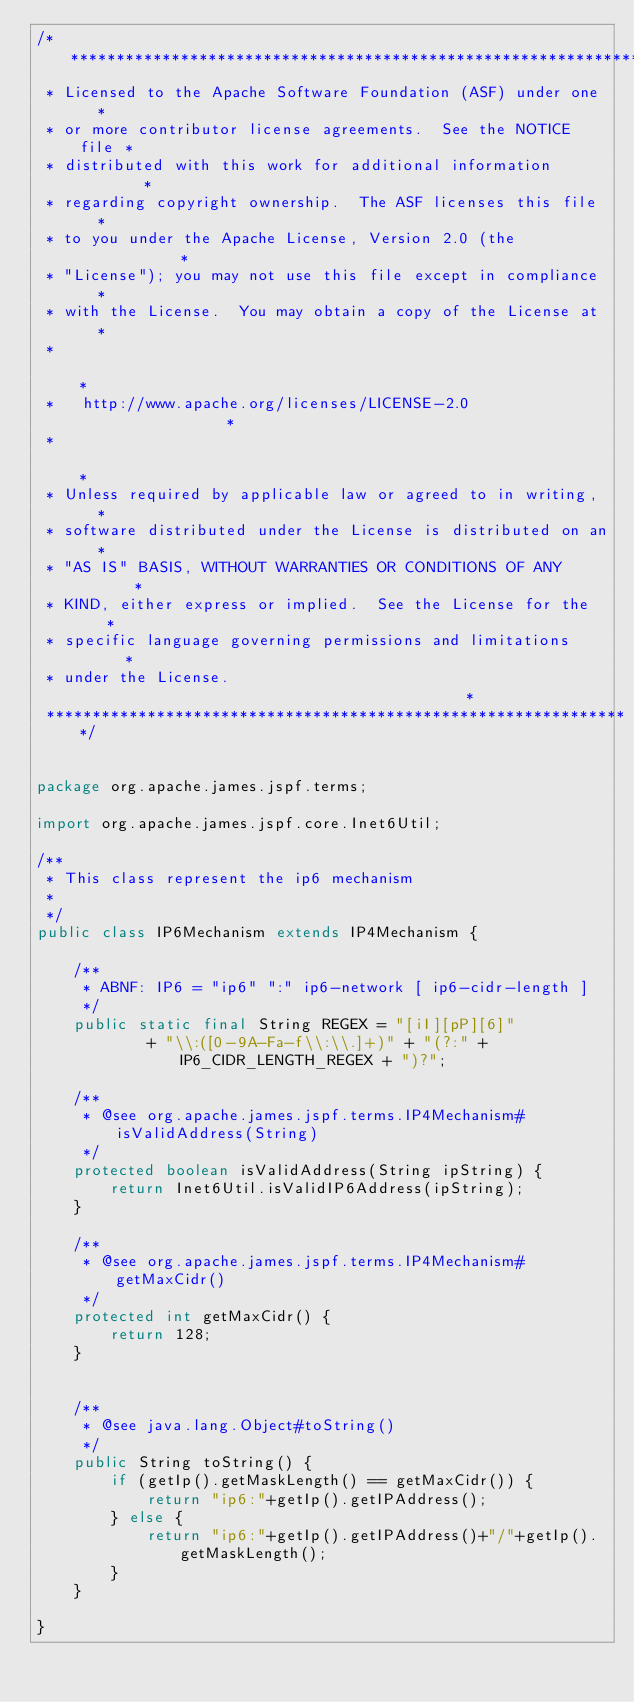Convert code to text. <code><loc_0><loc_0><loc_500><loc_500><_Java_>/****************************************************************
 * Licensed to the Apache Software Foundation (ASF) under one   *
 * or more contributor license agreements.  See the NOTICE file *
 * distributed with this work for additional information        *
 * regarding copyright ownership.  The ASF licenses this file   *
 * to you under the Apache License, Version 2.0 (the            *
 * "License"); you may not use this file except in compliance   *
 * with the License.  You may obtain a copy of the License at   *
 *                                                              *
 *   http://www.apache.org/licenses/LICENSE-2.0                 *
 *                                                              *
 * Unless required by applicable law or agreed to in writing,   *
 * software distributed under the License is distributed on an  *
 * "AS IS" BASIS, WITHOUT WARRANTIES OR CONDITIONS OF ANY       *
 * KIND, either express or implied.  See the License for the    *
 * specific language governing permissions and limitations      *
 * under the License.                                           *
 ****************************************************************/


package org.apache.james.jspf.terms;

import org.apache.james.jspf.core.Inet6Util;

/**
 * This class represent the ip6 mechanism
 * 
 */
public class IP6Mechanism extends IP4Mechanism {

    /**
     * ABNF: IP6 = "ip6" ":" ip6-network [ ip6-cidr-length ]
     */
    public static final String REGEX = "[iI][pP][6]"
            + "\\:([0-9A-Fa-f\\:\\.]+)" + "(?:" + IP6_CIDR_LENGTH_REGEX + ")?";

    /**
     * @see org.apache.james.jspf.terms.IP4Mechanism#isValidAddress(String)
     */
    protected boolean isValidAddress(String ipString) {
        return Inet6Util.isValidIP6Address(ipString);
    }

    /**
     * @see org.apache.james.jspf.terms.IP4Mechanism#getMaxCidr()
     */
    protected int getMaxCidr() {
        return 128;
    }
    

    /**
     * @see java.lang.Object#toString()
     */
    public String toString() {
        if (getIp().getMaskLength() == getMaxCidr()) {
            return "ip6:"+getIp().getIPAddress();
        } else {
            return "ip6:"+getIp().getIPAddress()+"/"+getIp().getMaskLength();
        }
    }

}
</code> 